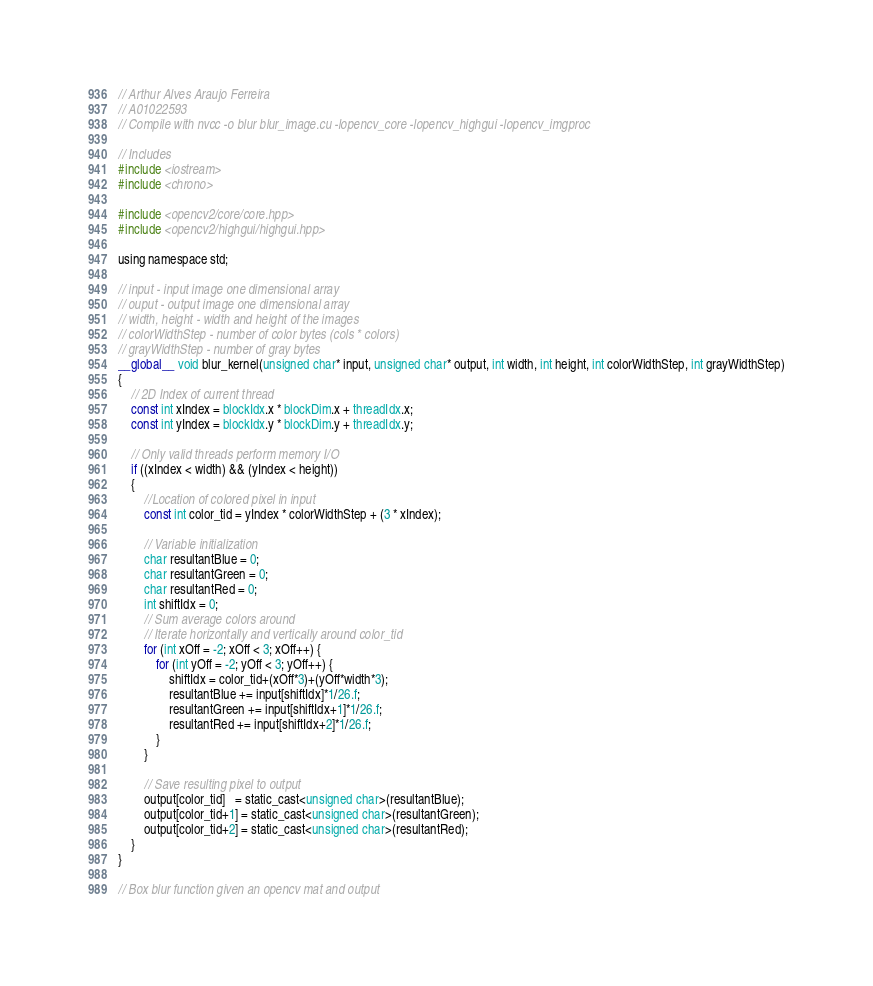Convert code to text. <code><loc_0><loc_0><loc_500><loc_500><_Cuda_>// Arthur Alves Araujo Ferreira
// A01022593
// Compile with nvcc -o blur blur_image.cu -lopencv_core -lopencv_highgui -lopencv_imgproc

// Includes
#include <iostream>
#include <chrono>

#include <opencv2/core/core.hpp>
#include <opencv2/highgui/highgui.hpp>

using namespace std;

// input - input image one dimensional array
// ouput - output image one dimensional array
// width, height - width and height of the images
// colorWidthStep - number of color bytes (cols * colors)
// grayWidthStep - number of gray bytes
__global__ void blur_kernel(unsigned char* input, unsigned char* output, int width, int height, int colorWidthStep, int grayWidthStep)
{
	// 2D Index of current thread
	const int xIndex = blockIdx.x * blockDim.x + threadIdx.x;
	const int yIndex = blockIdx.y * blockDim.y + threadIdx.y;

	// Only valid threads perform memory I/O
	if ((xIndex < width) && (yIndex < height))
	{
		//Location of colored pixel in input
		const int color_tid = yIndex * colorWidthStep + (3 * xIndex);

		// Variable initialization
		char resultantBlue = 0;
		char resultantGreen = 0;
		char resultantRed = 0;
		int shiftIdx = 0;
		// Sum average colors around
		// Iterate horizontally and vertically around color_tid
		for (int xOff = -2; xOff < 3; xOff++) {
			for (int yOff = -2; yOff < 3; yOff++) {
				shiftIdx = color_tid+(xOff*3)+(yOff*width*3);
				resultantBlue += input[shiftIdx]*1/26.f;
				resultantGreen += input[shiftIdx+1]*1/26.f;
				resultantRed += input[shiftIdx+2]*1/26.f;
			}
		}

		// Save resulting pixel to output
		output[color_tid]   = static_cast<unsigned char>(resultantBlue);
		output[color_tid+1] = static_cast<unsigned char>(resultantGreen);
		output[color_tid+2] = static_cast<unsigned char>(resultantRed);
	}
}

// Box blur function given an opencv mat and output</code> 